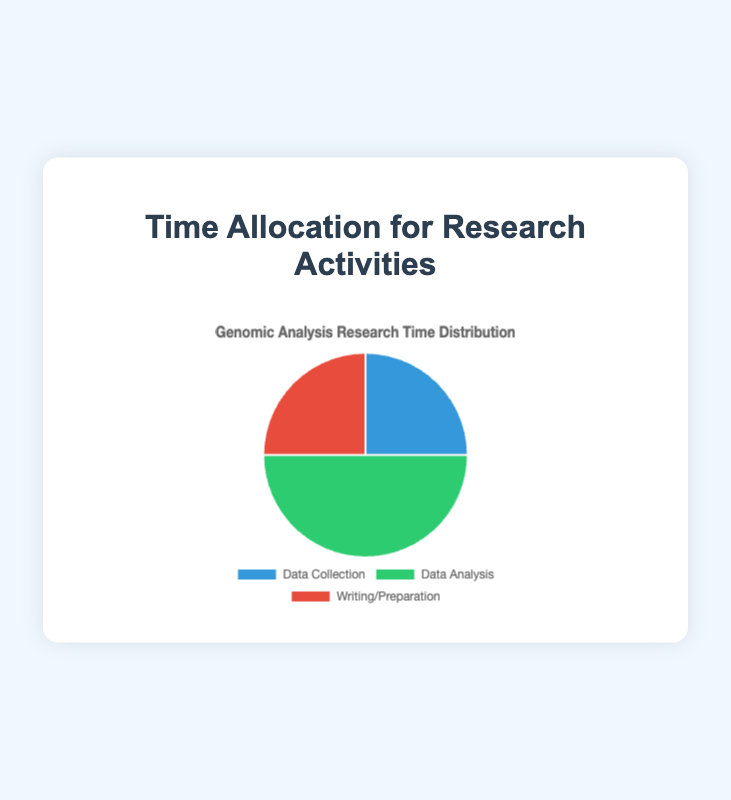What percentage of time is spent on Data Collection? The pie chart shows that Data Collection takes up 25% of the time allocation for research activities.
Answer: 25% How much more time is spent on Data Analysis compared to Writing/Preparation? The time spent on Data Analysis is 50%, and on Writing/Preparation is 25%. The difference is 50% - 25% = 25%.
Answer: 25% What is the total time percentage spent on activities other than Data Analysis? The time spent on activities other than Data Analysis is the sum of Data Collection and Writing/Preparation, which is 25% + 25% = 50%.
Answer: 50% Which research phase occupies the largest portion of time? The pie chart indicates that Data Analysis occupies the largest portion with 50%.
Answer: Data Analysis Are the time percentages for Data Collection and Writing/Preparation equal? Yes, both Data Collection and Writing/Preparation are allocated 25% of the time each.
Answer: Yes What is the difference between the highest and lowest time allocations? The highest time allocation is Data Analysis at 50%, and the lowest is either Data Collection or Writing/Preparation at 25%. The difference is 50% - 25% = 25%.
Answer: 25% What colors correspond to Data Analysis and Writing/Preparation on the pie chart? Data Analysis is represented in green, and Writing/Preparation is represented in red.
Answer: Green (Data Analysis), Red (Writing/Preparation) What percentage of time is allocated to Data Collection and Writing/Preparation combined? The time allocation for Data Collection and Writing/Preparation combined is 25% + 25% = 50%.
Answer: 50% If more time needs to be allocated equally between Data Collection and Writing/Preparation to equal Data Analysis, how much more percentage should be added to each? Data Collection and Writing/Preparation each have 25%, and Data Analysis has 50%, so to equal Data Analysis, each would need 50% - 25% = 25% more.
Answer: 25% more each What is the average percentage of time spent on the three research phases? The percentages for Data Collection, Data Analysis, and Writing/Preparation are 25%, 50%, and 25%. The average is (25% + 50% + 25%) / 3 = 100% / 3 ≈ 33.33%.
Answer: 33.33% 